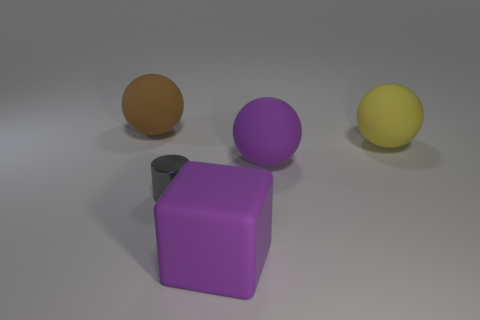Add 3 big red objects. How many objects exist? 8 Subtract all balls. How many objects are left? 2 Add 1 big green spheres. How many big green spheres exist? 1 Subtract 0 cyan cubes. How many objects are left? 5 Subtract all large red shiny cylinders. Subtract all big purple objects. How many objects are left? 3 Add 4 big purple matte cubes. How many big purple matte cubes are left? 5 